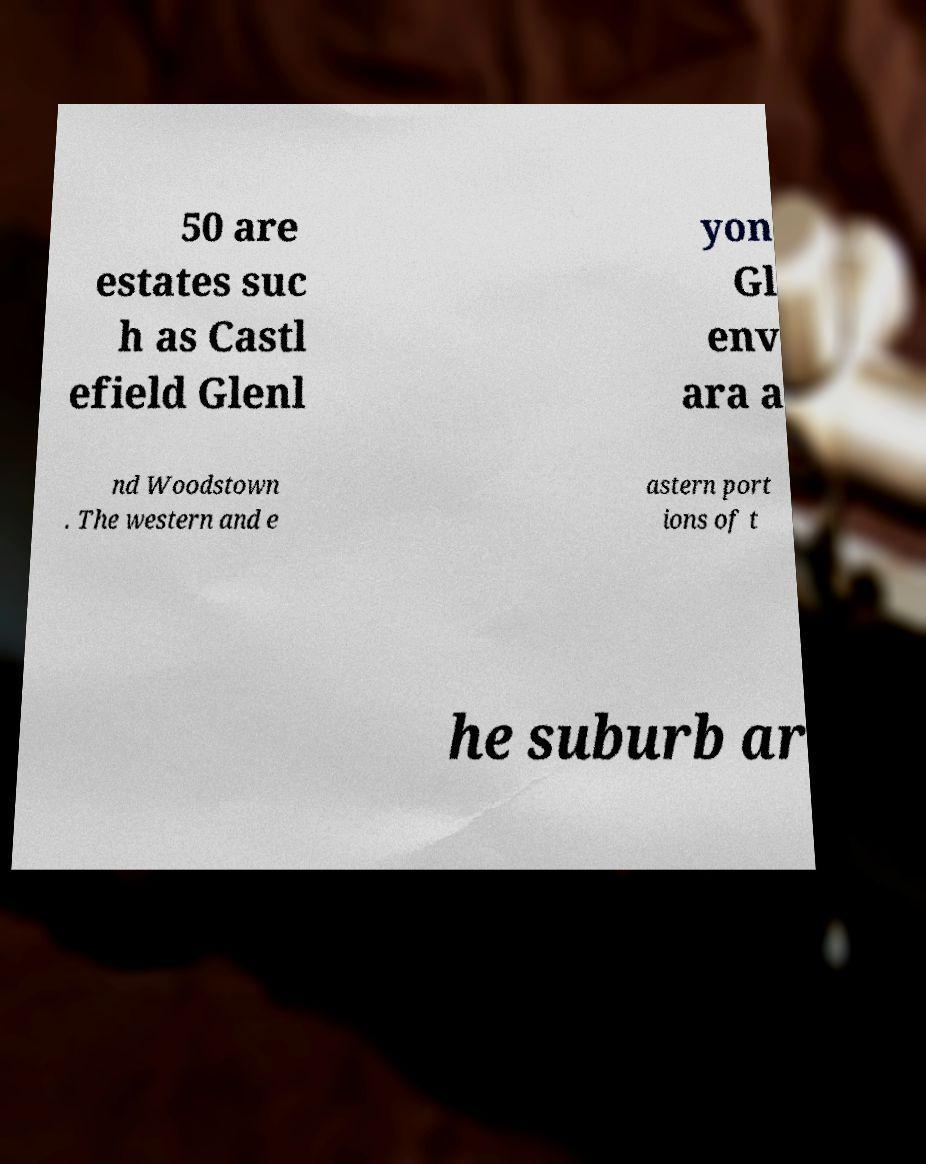For documentation purposes, I need the text within this image transcribed. Could you provide that? 50 are estates suc h as Castl efield Glenl yon Gl env ara a nd Woodstown . The western and e astern port ions of t he suburb ar 